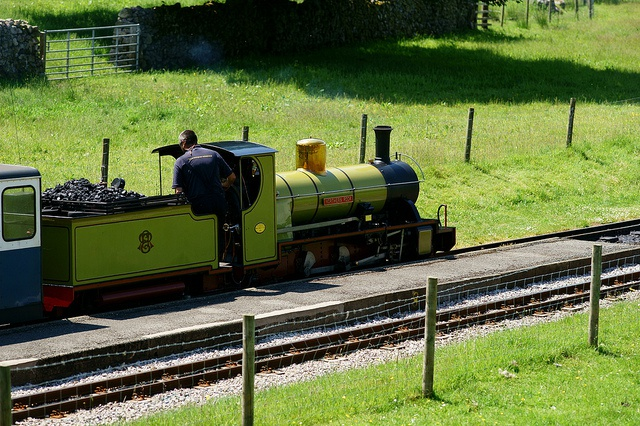Describe the objects in this image and their specific colors. I can see train in lightgreen, black, darkgreen, and gray tones and people in lightgreen, black, gray, and navy tones in this image. 